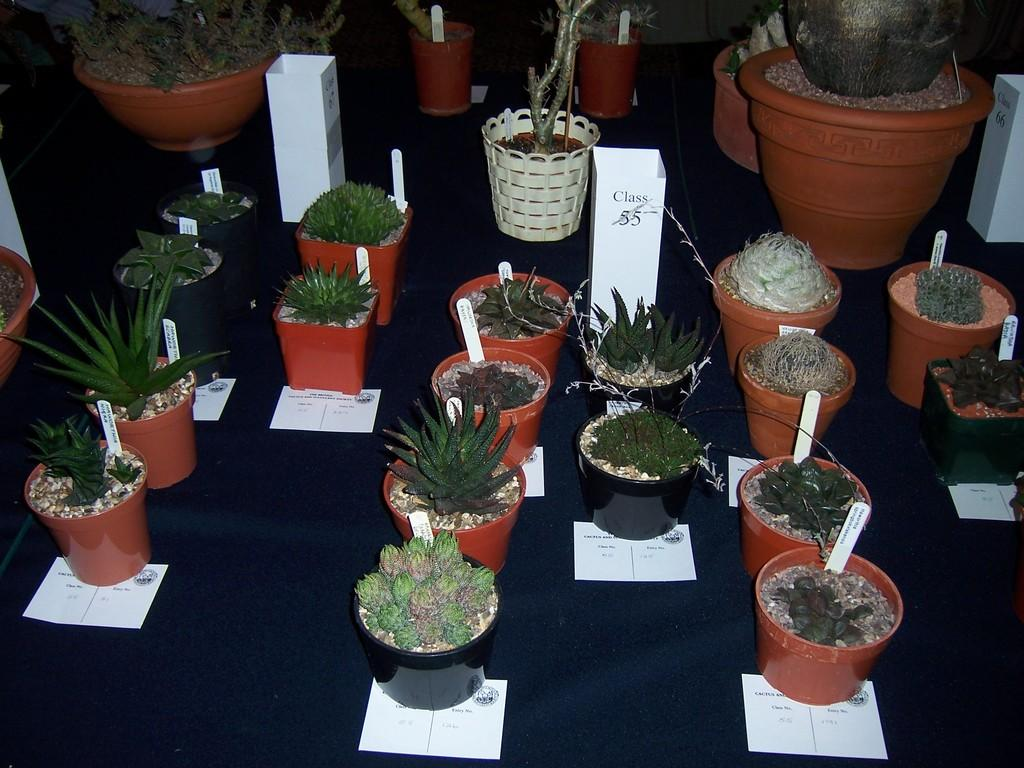What is located in the foreground of the image? There are potted plants in the foreground of the image. What can you tell me about the table in the image? The table is black in color. What type of paste is being used to make the vest in the image? There is no vest or paste present in the image; it features potted plants and a black table. Who made the request for the vest in the image? There is no request or vest present in the image. 